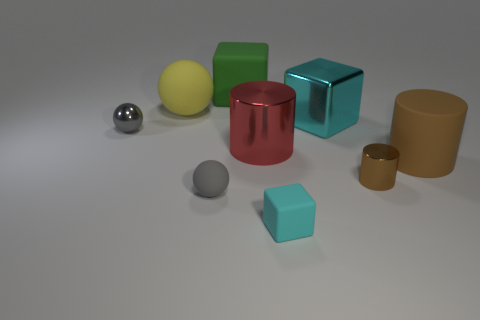Can you tell me if the lighting of the scene comes from a natural or artificial source? Given the uniformity and the soft shadows displayed, the lighting in this image likely originates from an artificial source, perhaps a simulated environment or a studio setup with controlled lighting. 